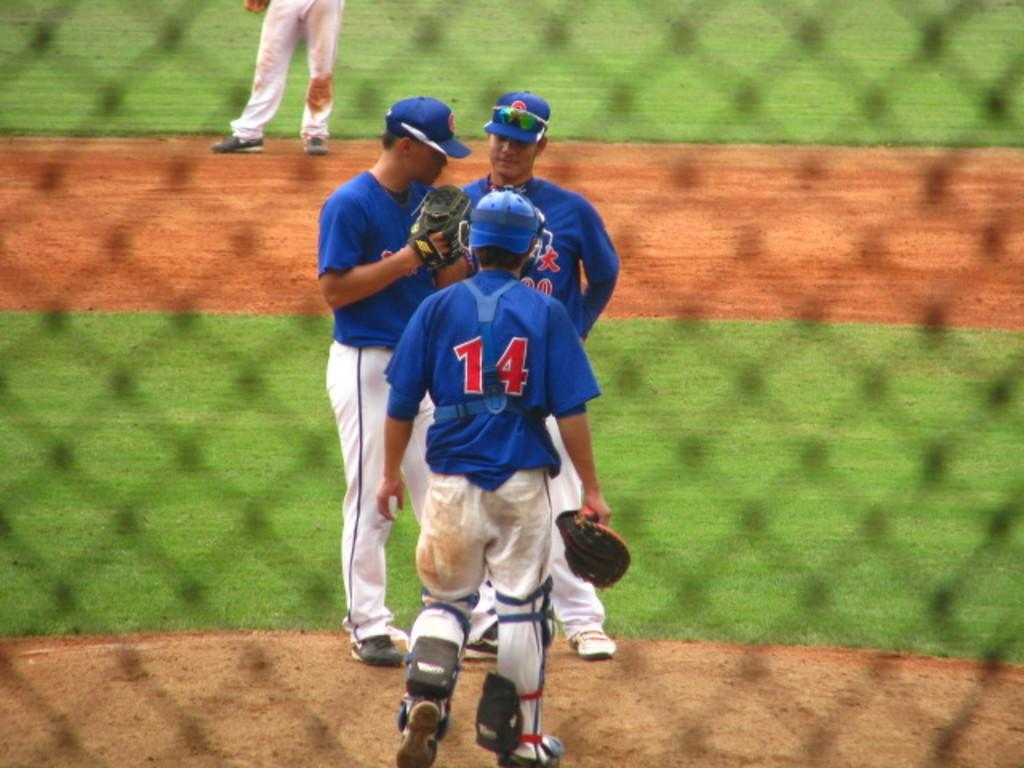<image>
Render a clear and concise summary of the photo. The baseball player with their back to us is wearing number 14. 